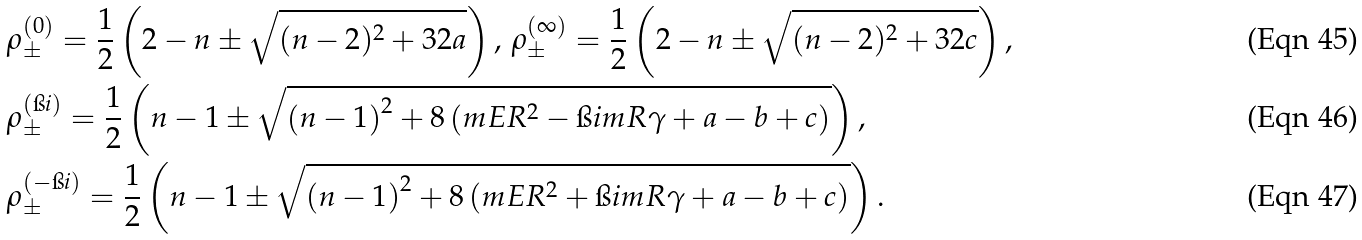<formula> <loc_0><loc_0><loc_500><loc_500>& \rho ^ { ( 0 ) } _ { \pm } = \frac { 1 } { 2 } \left ( 2 - n \pm \sqrt { ( n - 2 ) ^ { 2 } + 3 2 a } \right ) , \, \rho ^ { ( \infty ) } _ { \pm } = \frac { 1 } { 2 } \left ( 2 - n \pm \sqrt { ( n - 2 ) ^ { 2 } + 3 2 c } \right ) , \\ & \rho ^ { ( \i i ) } _ { \pm } = \frac { 1 } { 2 } \left ( n - 1 \pm \sqrt { \left ( n - 1 \right ) ^ { 2 } + 8 \left ( m E R ^ { 2 } - \i i m R \gamma + a - b + c \right ) } \right ) , \\ & \rho ^ { ( - \i i ) } _ { \pm } = \frac { 1 } { 2 } \left ( n - 1 \pm \sqrt { \left ( n - 1 \right ) ^ { 2 } + 8 \left ( m E R ^ { 2 } + \i i m R \gamma + a - b + c \right ) } \right ) .</formula> 